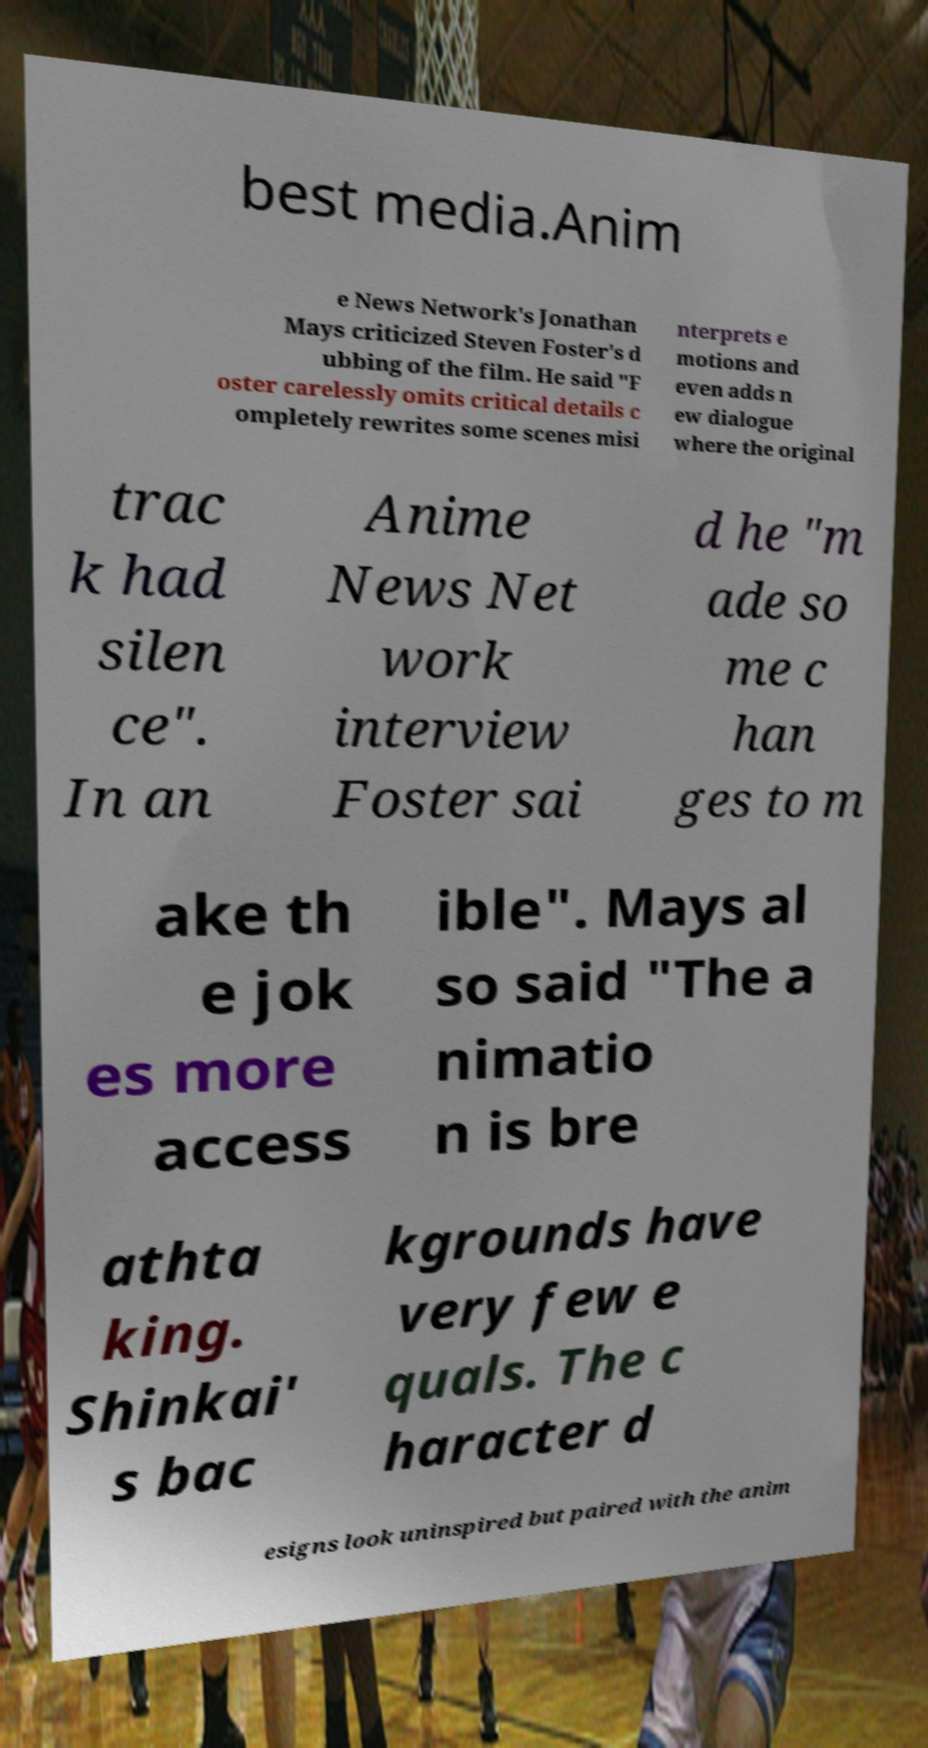For documentation purposes, I need the text within this image transcribed. Could you provide that? best media.Anim e News Network's Jonathan Mays criticized Steven Foster's d ubbing of the film. He said "F oster carelessly omits critical details c ompletely rewrites some scenes misi nterprets e motions and even adds n ew dialogue where the original trac k had silen ce". In an Anime News Net work interview Foster sai d he "m ade so me c han ges to m ake th e jok es more access ible". Mays al so said "The a nimatio n is bre athta king. Shinkai' s bac kgrounds have very few e quals. The c haracter d esigns look uninspired but paired with the anim 